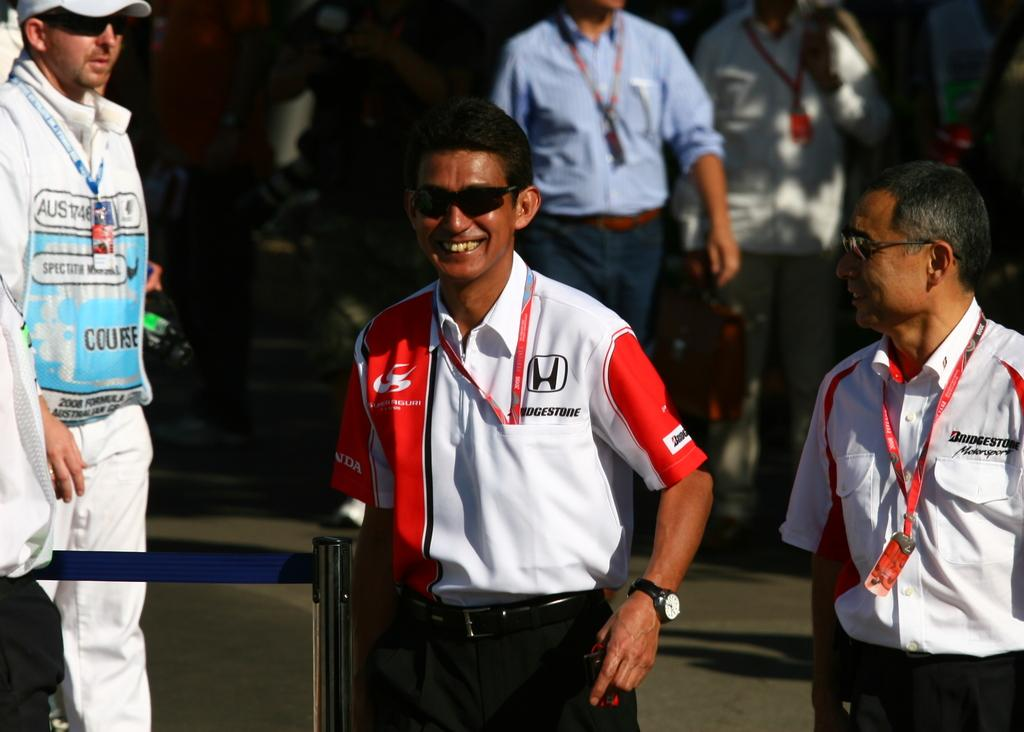<image>
Offer a succinct explanation of the picture presented. A pair of race driver smiling wearing Bridgestone sponsored shirts. 